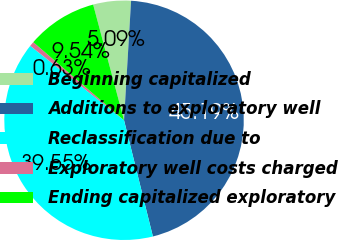Convert chart. <chart><loc_0><loc_0><loc_500><loc_500><pie_chart><fcel>Beginning capitalized<fcel>Additions to exploratory well<fcel>Reclassification due to<fcel>Exploratory well costs charged<fcel>Ending capitalized exploratory<nl><fcel>5.09%<fcel>45.19%<fcel>39.55%<fcel>0.63%<fcel>9.54%<nl></chart> 